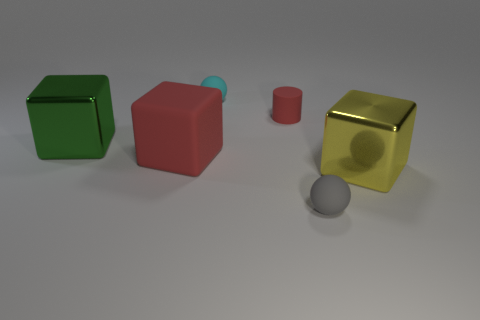Add 1 cyan metal spheres. How many objects exist? 7 Subtract all balls. How many objects are left? 4 Subtract 0 brown spheres. How many objects are left? 6 Subtract all things. Subtract all gray matte blocks. How many objects are left? 0 Add 1 blocks. How many blocks are left? 4 Add 6 blue shiny cylinders. How many blue shiny cylinders exist? 6 